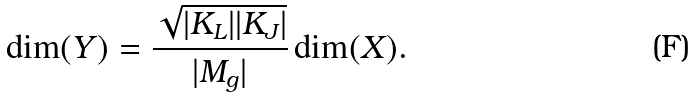<formula> <loc_0><loc_0><loc_500><loc_500>\dim ( Y ) = \frac { \sqrt { | K _ { L } | | K _ { J } | } } { | M _ { g } | } \dim ( X ) .</formula> 